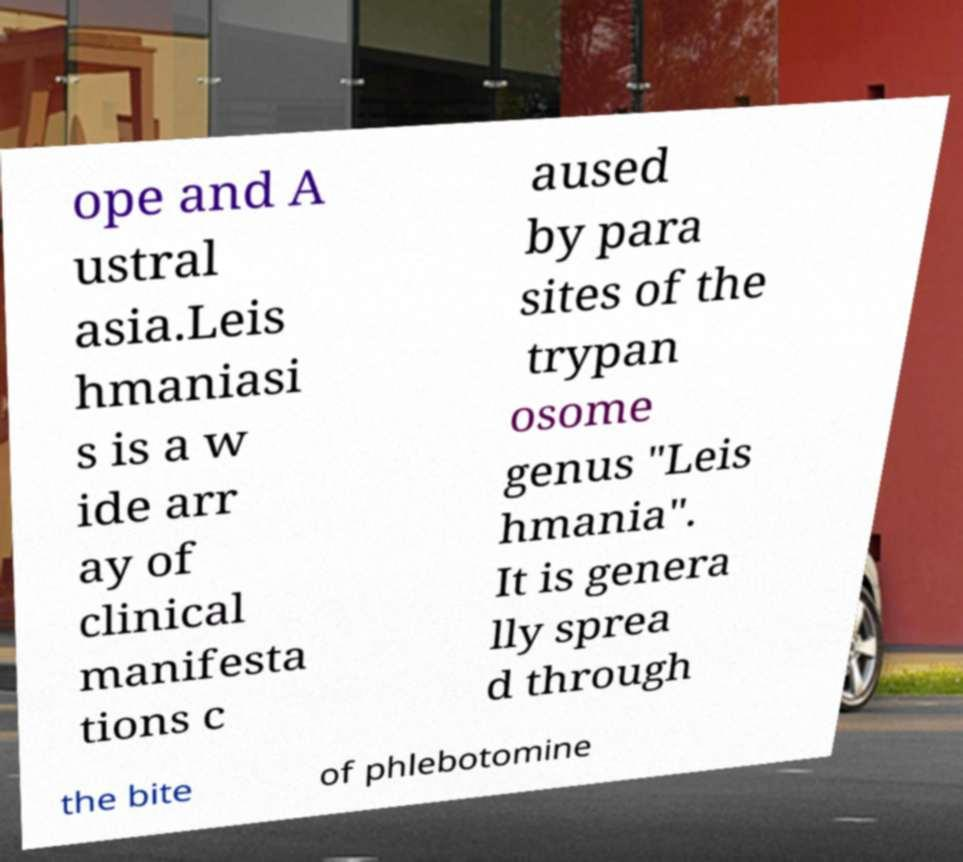Could you extract and type out the text from this image? ope and A ustral asia.Leis hmaniasi s is a w ide arr ay of clinical manifesta tions c aused by para sites of the trypan osome genus "Leis hmania". It is genera lly sprea d through the bite of phlebotomine 